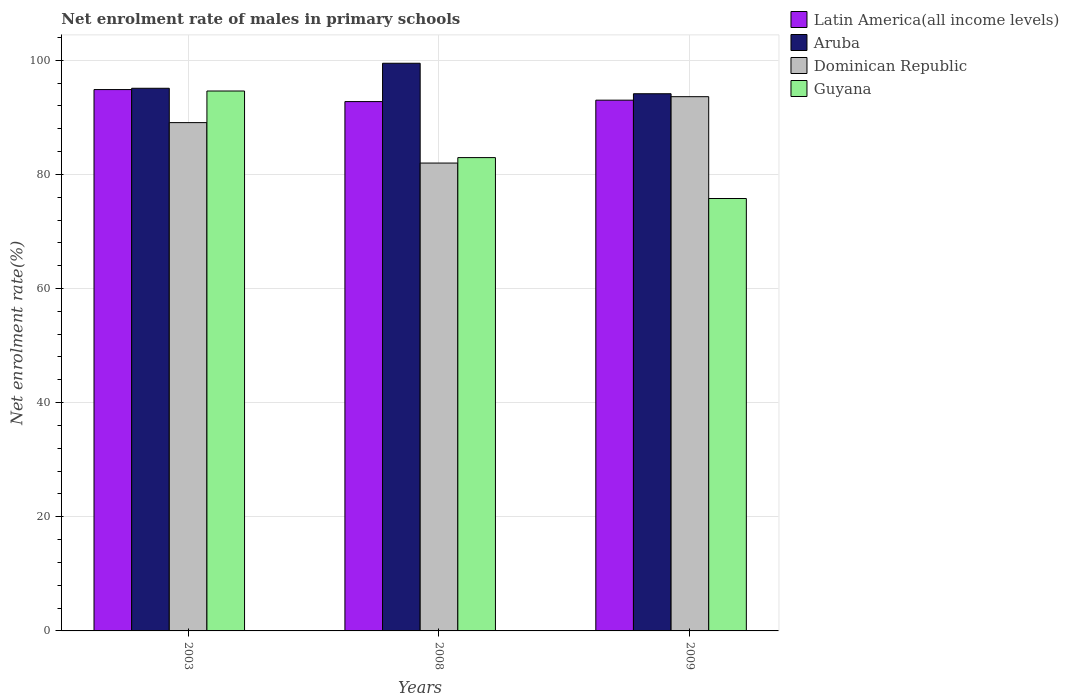How many different coloured bars are there?
Keep it short and to the point. 4. Are the number of bars per tick equal to the number of legend labels?
Offer a very short reply. Yes. Are the number of bars on each tick of the X-axis equal?
Provide a short and direct response. Yes. What is the label of the 2nd group of bars from the left?
Provide a succinct answer. 2008. In how many cases, is the number of bars for a given year not equal to the number of legend labels?
Ensure brevity in your answer.  0. What is the net enrolment rate of males in primary schools in Guyana in 2003?
Make the answer very short. 94.6. Across all years, what is the maximum net enrolment rate of males in primary schools in Dominican Republic?
Make the answer very short. 93.61. Across all years, what is the minimum net enrolment rate of males in primary schools in Aruba?
Make the answer very short. 94.12. In which year was the net enrolment rate of males in primary schools in Dominican Republic minimum?
Keep it short and to the point. 2008. What is the total net enrolment rate of males in primary schools in Guyana in the graph?
Provide a short and direct response. 253.3. What is the difference between the net enrolment rate of males in primary schools in Latin America(all income levels) in 2003 and that in 2009?
Make the answer very short. 1.86. What is the difference between the net enrolment rate of males in primary schools in Dominican Republic in 2008 and the net enrolment rate of males in primary schools in Latin America(all income levels) in 2003?
Give a very brief answer. -12.87. What is the average net enrolment rate of males in primary schools in Dominican Republic per year?
Offer a very short reply. 88.22. In the year 2003, what is the difference between the net enrolment rate of males in primary schools in Aruba and net enrolment rate of males in primary schools in Guyana?
Your response must be concise. 0.48. What is the ratio of the net enrolment rate of males in primary schools in Latin America(all income levels) in 2003 to that in 2008?
Offer a terse response. 1.02. Is the net enrolment rate of males in primary schools in Latin America(all income levels) in 2003 less than that in 2009?
Ensure brevity in your answer.  No. What is the difference between the highest and the second highest net enrolment rate of males in primary schools in Aruba?
Provide a succinct answer. 4.38. What is the difference between the highest and the lowest net enrolment rate of males in primary schools in Guyana?
Give a very brief answer. 18.84. What does the 1st bar from the left in 2008 represents?
Keep it short and to the point. Latin America(all income levels). What does the 4th bar from the right in 2003 represents?
Offer a very short reply. Latin America(all income levels). Are all the bars in the graph horizontal?
Offer a terse response. No. Are the values on the major ticks of Y-axis written in scientific E-notation?
Your answer should be very brief. No. Does the graph contain grids?
Your answer should be very brief. Yes. What is the title of the graph?
Offer a terse response. Net enrolment rate of males in primary schools. Does "Turkmenistan" appear as one of the legend labels in the graph?
Make the answer very short. No. What is the label or title of the Y-axis?
Offer a terse response. Net enrolment rate(%). What is the Net enrolment rate(%) of Latin America(all income levels) in 2003?
Offer a very short reply. 94.85. What is the Net enrolment rate(%) of Aruba in 2003?
Provide a short and direct response. 95.08. What is the Net enrolment rate(%) in Dominican Republic in 2003?
Your answer should be compact. 89.06. What is the Net enrolment rate(%) in Guyana in 2003?
Give a very brief answer. 94.6. What is the Net enrolment rate(%) in Latin America(all income levels) in 2008?
Your answer should be compact. 92.75. What is the Net enrolment rate(%) of Aruba in 2008?
Your answer should be compact. 99.46. What is the Net enrolment rate(%) in Dominican Republic in 2008?
Your response must be concise. 81.98. What is the Net enrolment rate(%) of Guyana in 2008?
Keep it short and to the point. 82.93. What is the Net enrolment rate(%) of Latin America(all income levels) in 2009?
Ensure brevity in your answer.  93. What is the Net enrolment rate(%) in Aruba in 2009?
Your answer should be very brief. 94.12. What is the Net enrolment rate(%) in Dominican Republic in 2009?
Your answer should be very brief. 93.61. What is the Net enrolment rate(%) of Guyana in 2009?
Offer a terse response. 75.77. Across all years, what is the maximum Net enrolment rate(%) of Latin America(all income levels)?
Offer a terse response. 94.85. Across all years, what is the maximum Net enrolment rate(%) in Aruba?
Offer a terse response. 99.46. Across all years, what is the maximum Net enrolment rate(%) of Dominican Republic?
Your answer should be compact. 93.61. Across all years, what is the maximum Net enrolment rate(%) of Guyana?
Make the answer very short. 94.6. Across all years, what is the minimum Net enrolment rate(%) in Latin America(all income levels)?
Your answer should be compact. 92.75. Across all years, what is the minimum Net enrolment rate(%) of Aruba?
Provide a succinct answer. 94.12. Across all years, what is the minimum Net enrolment rate(%) in Dominican Republic?
Your answer should be very brief. 81.98. Across all years, what is the minimum Net enrolment rate(%) of Guyana?
Offer a very short reply. 75.77. What is the total Net enrolment rate(%) in Latin America(all income levels) in the graph?
Offer a very short reply. 280.6. What is the total Net enrolment rate(%) in Aruba in the graph?
Your response must be concise. 288.67. What is the total Net enrolment rate(%) of Dominican Republic in the graph?
Offer a very short reply. 264.65. What is the total Net enrolment rate(%) of Guyana in the graph?
Ensure brevity in your answer.  253.3. What is the difference between the Net enrolment rate(%) of Latin America(all income levels) in 2003 and that in 2008?
Provide a short and direct response. 2.1. What is the difference between the Net enrolment rate(%) in Aruba in 2003 and that in 2008?
Provide a short and direct response. -4.38. What is the difference between the Net enrolment rate(%) in Dominican Republic in 2003 and that in 2008?
Your answer should be compact. 7.08. What is the difference between the Net enrolment rate(%) in Guyana in 2003 and that in 2008?
Keep it short and to the point. 11.67. What is the difference between the Net enrolment rate(%) in Latin America(all income levels) in 2003 and that in 2009?
Ensure brevity in your answer.  1.86. What is the difference between the Net enrolment rate(%) in Dominican Republic in 2003 and that in 2009?
Your answer should be very brief. -4.54. What is the difference between the Net enrolment rate(%) of Guyana in 2003 and that in 2009?
Offer a very short reply. 18.84. What is the difference between the Net enrolment rate(%) of Latin America(all income levels) in 2008 and that in 2009?
Your answer should be compact. -0.25. What is the difference between the Net enrolment rate(%) of Aruba in 2008 and that in 2009?
Provide a succinct answer. 5.34. What is the difference between the Net enrolment rate(%) in Dominican Republic in 2008 and that in 2009?
Keep it short and to the point. -11.63. What is the difference between the Net enrolment rate(%) of Guyana in 2008 and that in 2009?
Offer a very short reply. 7.17. What is the difference between the Net enrolment rate(%) of Latin America(all income levels) in 2003 and the Net enrolment rate(%) of Aruba in 2008?
Offer a terse response. -4.61. What is the difference between the Net enrolment rate(%) of Latin America(all income levels) in 2003 and the Net enrolment rate(%) of Dominican Republic in 2008?
Your answer should be compact. 12.87. What is the difference between the Net enrolment rate(%) in Latin America(all income levels) in 2003 and the Net enrolment rate(%) in Guyana in 2008?
Give a very brief answer. 11.92. What is the difference between the Net enrolment rate(%) of Aruba in 2003 and the Net enrolment rate(%) of Dominican Republic in 2008?
Your answer should be very brief. 13.1. What is the difference between the Net enrolment rate(%) in Aruba in 2003 and the Net enrolment rate(%) in Guyana in 2008?
Offer a terse response. 12.15. What is the difference between the Net enrolment rate(%) in Dominican Republic in 2003 and the Net enrolment rate(%) in Guyana in 2008?
Ensure brevity in your answer.  6.13. What is the difference between the Net enrolment rate(%) of Latin America(all income levels) in 2003 and the Net enrolment rate(%) of Aruba in 2009?
Your response must be concise. 0.73. What is the difference between the Net enrolment rate(%) in Latin America(all income levels) in 2003 and the Net enrolment rate(%) in Dominican Republic in 2009?
Provide a succinct answer. 1.25. What is the difference between the Net enrolment rate(%) of Latin America(all income levels) in 2003 and the Net enrolment rate(%) of Guyana in 2009?
Your response must be concise. 19.09. What is the difference between the Net enrolment rate(%) in Aruba in 2003 and the Net enrolment rate(%) in Dominican Republic in 2009?
Keep it short and to the point. 1.47. What is the difference between the Net enrolment rate(%) of Aruba in 2003 and the Net enrolment rate(%) of Guyana in 2009?
Provide a succinct answer. 19.32. What is the difference between the Net enrolment rate(%) in Dominican Republic in 2003 and the Net enrolment rate(%) in Guyana in 2009?
Make the answer very short. 13.3. What is the difference between the Net enrolment rate(%) of Latin America(all income levels) in 2008 and the Net enrolment rate(%) of Aruba in 2009?
Make the answer very short. -1.37. What is the difference between the Net enrolment rate(%) in Latin America(all income levels) in 2008 and the Net enrolment rate(%) in Dominican Republic in 2009?
Ensure brevity in your answer.  -0.86. What is the difference between the Net enrolment rate(%) of Latin America(all income levels) in 2008 and the Net enrolment rate(%) of Guyana in 2009?
Offer a very short reply. 16.98. What is the difference between the Net enrolment rate(%) of Aruba in 2008 and the Net enrolment rate(%) of Dominican Republic in 2009?
Provide a short and direct response. 5.86. What is the difference between the Net enrolment rate(%) in Aruba in 2008 and the Net enrolment rate(%) in Guyana in 2009?
Provide a short and direct response. 23.7. What is the difference between the Net enrolment rate(%) of Dominican Republic in 2008 and the Net enrolment rate(%) of Guyana in 2009?
Give a very brief answer. 6.21. What is the average Net enrolment rate(%) in Latin America(all income levels) per year?
Your answer should be very brief. 93.53. What is the average Net enrolment rate(%) of Aruba per year?
Provide a succinct answer. 96.22. What is the average Net enrolment rate(%) of Dominican Republic per year?
Offer a very short reply. 88.22. What is the average Net enrolment rate(%) of Guyana per year?
Make the answer very short. 84.43. In the year 2003, what is the difference between the Net enrolment rate(%) of Latin America(all income levels) and Net enrolment rate(%) of Aruba?
Your answer should be compact. -0.23. In the year 2003, what is the difference between the Net enrolment rate(%) of Latin America(all income levels) and Net enrolment rate(%) of Dominican Republic?
Ensure brevity in your answer.  5.79. In the year 2003, what is the difference between the Net enrolment rate(%) of Latin America(all income levels) and Net enrolment rate(%) of Guyana?
Provide a succinct answer. 0.25. In the year 2003, what is the difference between the Net enrolment rate(%) of Aruba and Net enrolment rate(%) of Dominican Republic?
Ensure brevity in your answer.  6.02. In the year 2003, what is the difference between the Net enrolment rate(%) in Aruba and Net enrolment rate(%) in Guyana?
Your answer should be compact. 0.48. In the year 2003, what is the difference between the Net enrolment rate(%) of Dominican Republic and Net enrolment rate(%) of Guyana?
Ensure brevity in your answer.  -5.54. In the year 2008, what is the difference between the Net enrolment rate(%) in Latin America(all income levels) and Net enrolment rate(%) in Aruba?
Keep it short and to the point. -6.71. In the year 2008, what is the difference between the Net enrolment rate(%) of Latin America(all income levels) and Net enrolment rate(%) of Dominican Republic?
Your response must be concise. 10.77. In the year 2008, what is the difference between the Net enrolment rate(%) of Latin America(all income levels) and Net enrolment rate(%) of Guyana?
Make the answer very short. 9.82. In the year 2008, what is the difference between the Net enrolment rate(%) in Aruba and Net enrolment rate(%) in Dominican Republic?
Ensure brevity in your answer.  17.48. In the year 2008, what is the difference between the Net enrolment rate(%) of Aruba and Net enrolment rate(%) of Guyana?
Offer a very short reply. 16.53. In the year 2008, what is the difference between the Net enrolment rate(%) of Dominican Republic and Net enrolment rate(%) of Guyana?
Offer a very short reply. -0.95. In the year 2009, what is the difference between the Net enrolment rate(%) in Latin America(all income levels) and Net enrolment rate(%) in Aruba?
Keep it short and to the point. -1.12. In the year 2009, what is the difference between the Net enrolment rate(%) in Latin America(all income levels) and Net enrolment rate(%) in Dominican Republic?
Provide a short and direct response. -0.61. In the year 2009, what is the difference between the Net enrolment rate(%) of Latin America(all income levels) and Net enrolment rate(%) of Guyana?
Your response must be concise. 17.23. In the year 2009, what is the difference between the Net enrolment rate(%) of Aruba and Net enrolment rate(%) of Dominican Republic?
Keep it short and to the point. 0.52. In the year 2009, what is the difference between the Net enrolment rate(%) in Aruba and Net enrolment rate(%) in Guyana?
Offer a terse response. 18.36. In the year 2009, what is the difference between the Net enrolment rate(%) of Dominican Republic and Net enrolment rate(%) of Guyana?
Offer a terse response. 17.84. What is the ratio of the Net enrolment rate(%) in Latin America(all income levels) in 2003 to that in 2008?
Offer a very short reply. 1.02. What is the ratio of the Net enrolment rate(%) in Aruba in 2003 to that in 2008?
Ensure brevity in your answer.  0.96. What is the ratio of the Net enrolment rate(%) of Dominican Republic in 2003 to that in 2008?
Offer a terse response. 1.09. What is the ratio of the Net enrolment rate(%) of Guyana in 2003 to that in 2008?
Make the answer very short. 1.14. What is the ratio of the Net enrolment rate(%) in Latin America(all income levels) in 2003 to that in 2009?
Provide a short and direct response. 1.02. What is the ratio of the Net enrolment rate(%) of Aruba in 2003 to that in 2009?
Make the answer very short. 1.01. What is the ratio of the Net enrolment rate(%) of Dominican Republic in 2003 to that in 2009?
Your response must be concise. 0.95. What is the ratio of the Net enrolment rate(%) of Guyana in 2003 to that in 2009?
Your response must be concise. 1.25. What is the ratio of the Net enrolment rate(%) of Latin America(all income levels) in 2008 to that in 2009?
Offer a very short reply. 1. What is the ratio of the Net enrolment rate(%) in Aruba in 2008 to that in 2009?
Give a very brief answer. 1.06. What is the ratio of the Net enrolment rate(%) of Dominican Republic in 2008 to that in 2009?
Offer a very short reply. 0.88. What is the ratio of the Net enrolment rate(%) of Guyana in 2008 to that in 2009?
Offer a very short reply. 1.09. What is the difference between the highest and the second highest Net enrolment rate(%) of Latin America(all income levels)?
Offer a terse response. 1.86. What is the difference between the highest and the second highest Net enrolment rate(%) in Aruba?
Provide a short and direct response. 4.38. What is the difference between the highest and the second highest Net enrolment rate(%) of Dominican Republic?
Keep it short and to the point. 4.54. What is the difference between the highest and the second highest Net enrolment rate(%) in Guyana?
Keep it short and to the point. 11.67. What is the difference between the highest and the lowest Net enrolment rate(%) in Latin America(all income levels)?
Your answer should be very brief. 2.1. What is the difference between the highest and the lowest Net enrolment rate(%) in Aruba?
Your answer should be very brief. 5.34. What is the difference between the highest and the lowest Net enrolment rate(%) of Dominican Republic?
Offer a terse response. 11.63. What is the difference between the highest and the lowest Net enrolment rate(%) of Guyana?
Give a very brief answer. 18.84. 